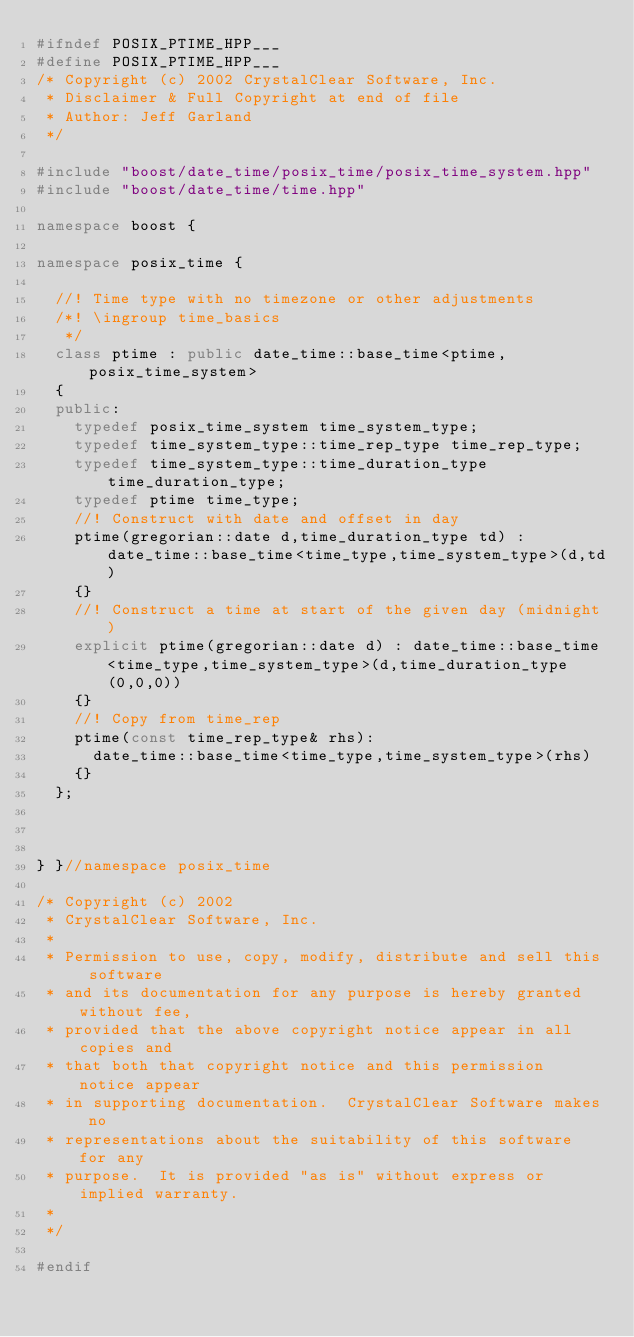Convert code to text. <code><loc_0><loc_0><loc_500><loc_500><_C++_>#ifndef POSIX_PTIME_HPP___
#define POSIX_PTIME_HPP___
/* Copyright (c) 2002 CrystalClear Software, Inc.
 * Disclaimer & Full Copyright at end of file
 * Author: Jeff Garland 
 */

#include "boost/date_time/posix_time/posix_time_system.hpp"
#include "boost/date_time/time.hpp"

namespace boost {

namespace posix_time {
  
  //! Time type with no timezone or other adjustments
  /*! \ingroup time_basics
   */
  class ptime : public date_time::base_time<ptime, posix_time_system>
  {
  public:
    typedef posix_time_system time_system_type;
    typedef time_system_type::time_rep_type time_rep_type;
    typedef time_system_type::time_duration_type time_duration_type;
    typedef ptime time_type;
    //! Construct with date and offset in day
    ptime(gregorian::date d,time_duration_type td) : date_time::base_time<time_type,time_system_type>(d,td)
    {}
    //! Construct a time at start of the given day (midnight)
    explicit ptime(gregorian::date d) : date_time::base_time<time_type,time_system_type>(d,time_duration_type(0,0,0))
    {}
    //! Copy from time_rep
    ptime(const time_rep_type& rhs):
      date_time::base_time<time_type,time_system_type>(rhs)
    {}
  };



} }//namespace posix_time

/* Copyright (c) 2002
 * CrystalClear Software, Inc.
 *
 * Permission to use, copy, modify, distribute and sell this software
 * and its documentation for any purpose is hereby granted without fee,
 * provided that the above copyright notice appear in all copies and
 * that both that copyright notice and this permission notice appear
 * in supporting documentation.  CrystalClear Software makes no
 * representations about the suitability of this software for any
 * purpose.  It is provided "as is" without express or implied warranty.
 *
 */

#endif

</code> 